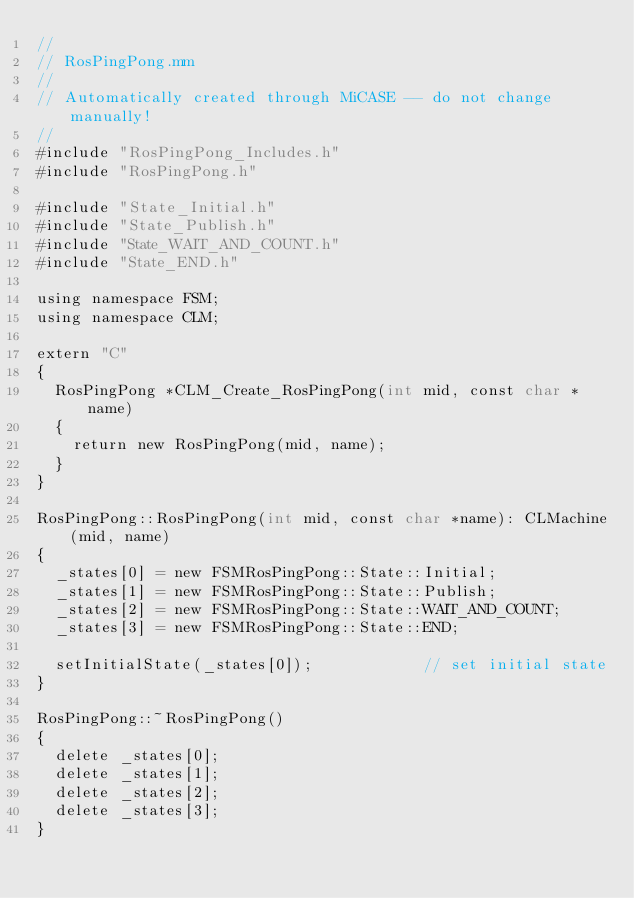Convert code to text. <code><loc_0><loc_0><loc_500><loc_500><_ObjectiveC_>//
// RosPingPong.mm
//
// Automatically created through MiCASE -- do not change manually!
//
#include "RosPingPong_Includes.h"
#include "RosPingPong.h"

#include "State_Initial.h"
#include "State_Publish.h"
#include "State_WAIT_AND_COUNT.h"
#include "State_END.h"

using namespace FSM;
using namespace CLM;

extern "C"
{
	RosPingPong *CLM_Create_RosPingPong(int mid, const char *name)
	{
		return new RosPingPong(mid, name);
	}
}

RosPingPong::RosPingPong(int mid, const char *name): CLMachine(mid, name)
{
	_states[0] = new FSMRosPingPong::State::Initial;
	_states[1] = new FSMRosPingPong::State::Publish;
	_states[2] = new FSMRosPingPong::State::WAIT_AND_COUNT;
	_states[3] = new FSMRosPingPong::State::END;

	setInitialState(_states[0]);            // set initial state
}

RosPingPong::~RosPingPong()
{
	delete _states[0];
	delete _states[1];
	delete _states[2];
	delete _states[3];
}
</code> 